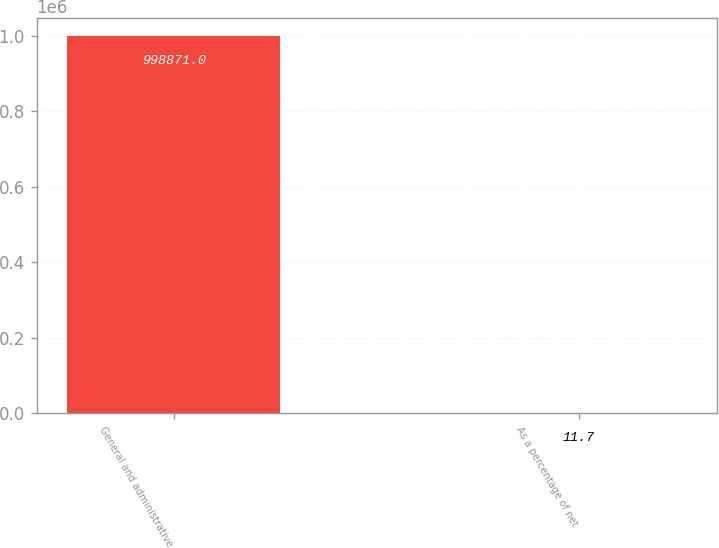Convert chart. <chart><loc_0><loc_0><loc_500><loc_500><bar_chart><fcel>General and administrative<fcel>As a percentage of net<nl><fcel>998871<fcel>11.7<nl></chart> 